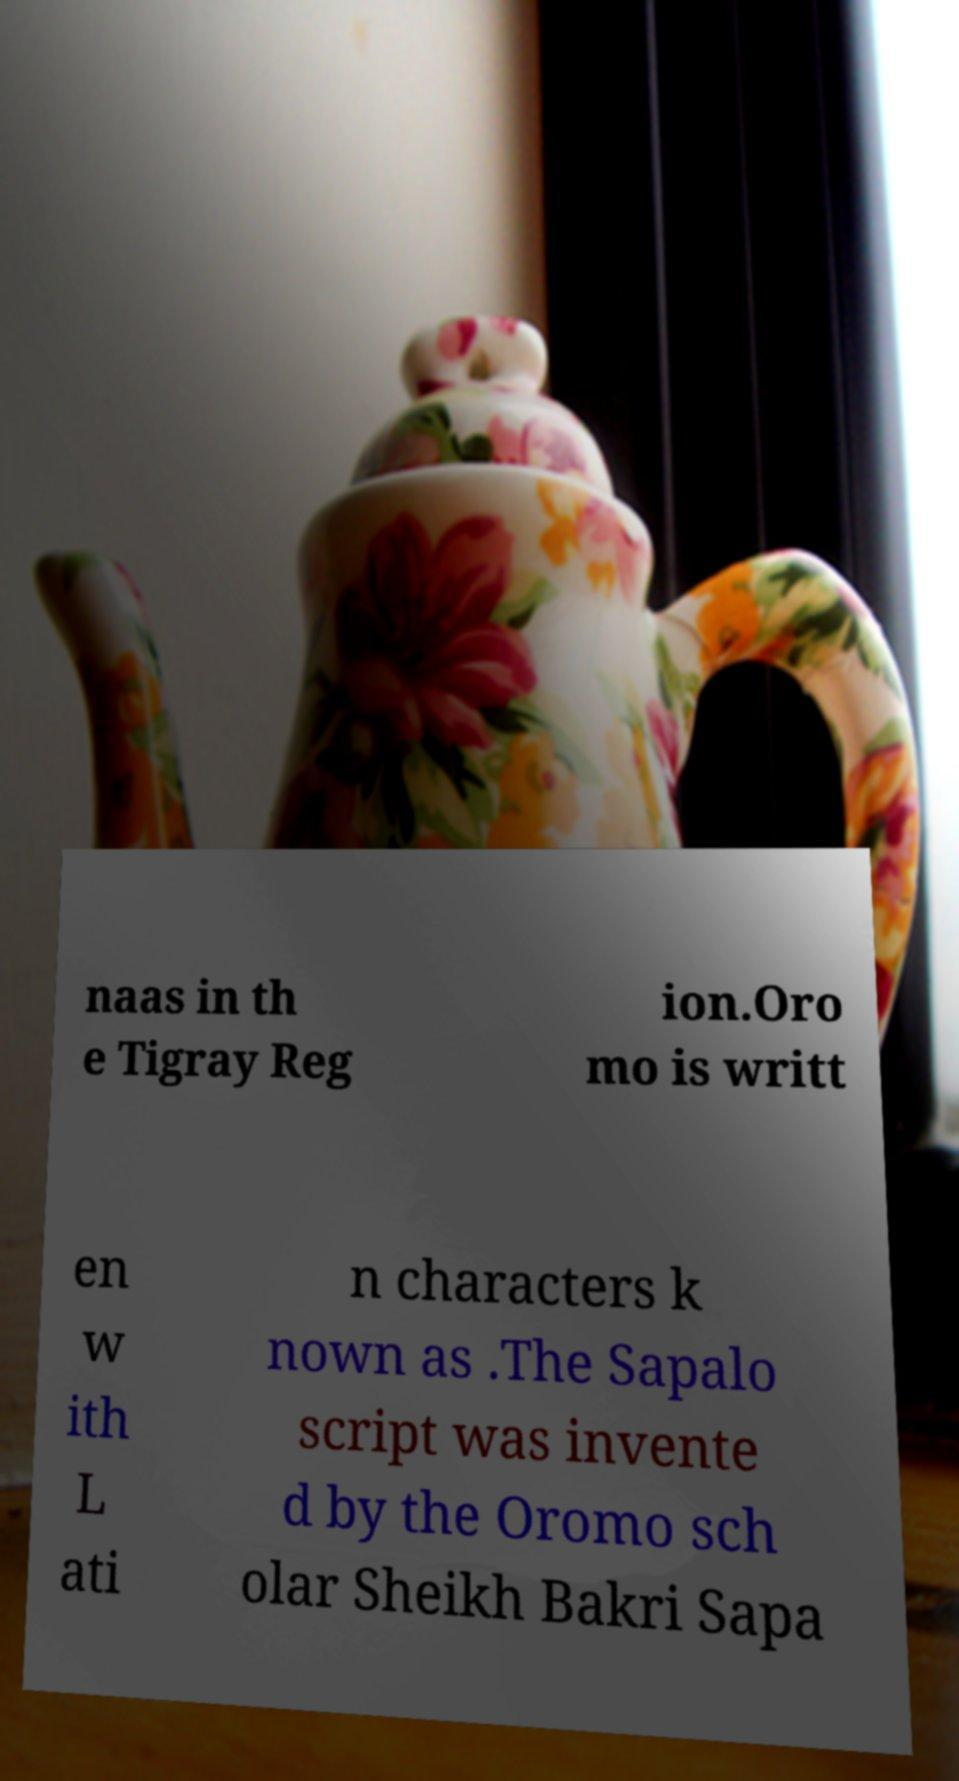What messages or text are displayed in this image? I need them in a readable, typed format. naas in th e Tigray Reg ion.Oro mo is writt en w ith L ati n characters k nown as .The Sapalo script was invente d by the Oromo sch olar Sheikh Bakri Sapa 